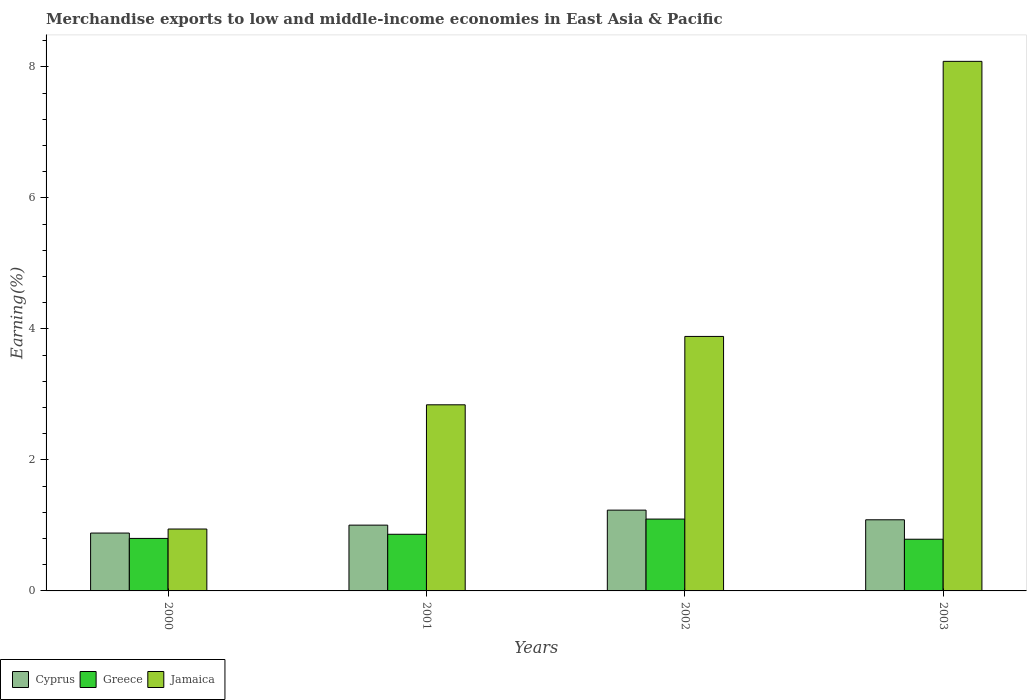How many groups of bars are there?
Provide a succinct answer. 4. Are the number of bars per tick equal to the number of legend labels?
Give a very brief answer. Yes. What is the label of the 1st group of bars from the left?
Your answer should be very brief. 2000. What is the percentage of amount earned from merchandise exports in Cyprus in 2003?
Ensure brevity in your answer.  1.09. Across all years, what is the maximum percentage of amount earned from merchandise exports in Greece?
Give a very brief answer. 1.1. Across all years, what is the minimum percentage of amount earned from merchandise exports in Greece?
Keep it short and to the point. 0.79. In which year was the percentage of amount earned from merchandise exports in Cyprus maximum?
Offer a very short reply. 2002. In which year was the percentage of amount earned from merchandise exports in Jamaica minimum?
Provide a succinct answer. 2000. What is the total percentage of amount earned from merchandise exports in Jamaica in the graph?
Make the answer very short. 15.76. What is the difference between the percentage of amount earned from merchandise exports in Cyprus in 2000 and that in 2001?
Provide a short and direct response. -0.12. What is the difference between the percentage of amount earned from merchandise exports in Greece in 2001 and the percentage of amount earned from merchandise exports in Cyprus in 2002?
Give a very brief answer. -0.37. What is the average percentage of amount earned from merchandise exports in Greece per year?
Make the answer very short. 0.89. In the year 2000, what is the difference between the percentage of amount earned from merchandise exports in Cyprus and percentage of amount earned from merchandise exports in Jamaica?
Ensure brevity in your answer.  -0.06. What is the ratio of the percentage of amount earned from merchandise exports in Cyprus in 2001 to that in 2002?
Provide a succinct answer. 0.81. Is the percentage of amount earned from merchandise exports in Greece in 2001 less than that in 2002?
Provide a succinct answer. Yes. Is the difference between the percentage of amount earned from merchandise exports in Cyprus in 2002 and 2003 greater than the difference between the percentage of amount earned from merchandise exports in Jamaica in 2002 and 2003?
Give a very brief answer. Yes. What is the difference between the highest and the second highest percentage of amount earned from merchandise exports in Jamaica?
Offer a very short reply. 4.2. What is the difference between the highest and the lowest percentage of amount earned from merchandise exports in Greece?
Make the answer very short. 0.31. In how many years, is the percentage of amount earned from merchandise exports in Cyprus greater than the average percentage of amount earned from merchandise exports in Cyprus taken over all years?
Ensure brevity in your answer.  2. Is the sum of the percentage of amount earned from merchandise exports in Cyprus in 2000 and 2003 greater than the maximum percentage of amount earned from merchandise exports in Jamaica across all years?
Provide a short and direct response. No. What does the 3rd bar from the left in 2000 represents?
Your answer should be very brief. Jamaica. What does the 3rd bar from the right in 2001 represents?
Your response must be concise. Cyprus. How many years are there in the graph?
Your answer should be very brief. 4. Are the values on the major ticks of Y-axis written in scientific E-notation?
Provide a succinct answer. No. Where does the legend appear in the graph?
Keep it short and to the point. Bottom left. What is the title of the graph?
Provide a succinct answer. Merchandise exports to low and middle-income economies in East Asia & Pacific. Does "Zimbabwe" appear as one of the legend labels in the graph?
Keep it short and to the point. No. What is the label or title of the X-axis?
Keep it short and to the point. Years. What is the label or title of the Y-axis?
Make the answer very short. Earning(%). What is the Earning(%) in Cyprus in 2000?
Provide a short and direct response. 0.88. What is the Earning(%) of Greece in 2000?
Ensure brevity in your answer.  0.8. What is the Earning(%) in Jamaica in 2000?
Offer a very short reply. 0.94. What is the Earning(%) of Cyprus in 2001?
Offer a terse response. 1. What is the Earning(%) in Greece in 2001?
Offer a very short reply. 0.86. What is the Earning(%) of Jamaica in 2001?
Your answer should be compact. 2.84. What is the Earning(%) of Cyprus in 2002?
Offer a terse response. 1.23. What is the Earning(%) of Greece in 2002?
Give a very brief answer. 1.1. What is the Earning(%) in Jamaica in 2002?
Provide a short and direct response. 3.89. What is the Earning(%) of Cyprus in 2003?
Provide a short and direct response. 1.09. What is the Earning(%) in Greece in 2003?
Provide a succinct answer. 0.79. What is the Earning(%) in Jamaica in 2003?
Provide a succinct answer. 8.08. Across all years, what is the maximum Earning(%) of Cyprus?
Your response must be concise. 1.23. Across all years, what is the maximum Earning(%) in Greece?
Offer a terse response. 1.1. Across all years, what is the maximum Earning(%) in Jamaica?
Keep it short and to the point. 8.08. Across all years, what is the minimum Earning(%) in Cyprus?
Make the answer very short. 0.88. Across all years, what is the minimum Earning(%) in Greece?
Offer a terse response. 0.79. Across all years, what is the minimum Earning(%) in Jamaica?
Keep it short and to the point. 0.94. What is the total Earning(%) in Cyprus in the graph?
Offer a very short reply. 4.21. What is the total Earning(%) in Greece in the graph?
Offer a terse response. 3.55. What is the total Earning(%) in Jamaica in the graph?
Provide a succinct answer. 15.76. What is the difference between the Earning(%) in Cyprus in 2000 and that in 2001?
Your answer should be compact. -0.12. What is the difference between the Earning(%) of Greece in 2000 and that in 2001?
Offer a terse response. -0.06. What is the difference between the Earning(%) in Jamaica in 2000 and that in 2001?
Offer a terse response. -1.9. What is the difference between the Earning(%) of Cyprus in 2000 and that in 2002?
Your response must be concise. -0.35. What is the difference between the Earning(%) in Greece in 2000 and that in 2002?
Offer a very short reply. -0.3. What is the difference between the Earning(%) in Jamaica in 2000 and that in 2002?
Your answer should be very brief. -2.94. What is the difference between the Earning(%) in Cyprus in 2000 and that in 2003?
Your response must be concise. -0.2. What is the difference between the Earning(%) of Greece in 2000 and that in 2003?
Provide a succinct answer. 0.01. What is the difference between the Earning(%) of Jamaica in 2000 and that in 2003?
Provide a succinct answer. -7.14. What is the difference between the Earning(%) in Cyprus in 2001 and that in 2002?
Make the answer very short. -0.23. What is the difference between the Earning(%) in Greece in 2001 and that in 2002?
Your response must be concise. -0.23. What is the difference between the Earning(%) of Jamaica in 2001 and that in 2002?
Keep it short and to the point. -1.04. What is the difference between the Earning(%) of Cyprus in 2001 and that in 2003?
Your answer should be compact. -0.08. What is the difference between the Earning(%) of Greece in 2001 and that in 2003?
Provide a succinct answer. 0.08. What is the difference between the Earning(%) in Jamaica in 2001 and that in 2003?
Provide a succinct answer. -5.24. What is the difference between the Earning(%) of Cyprus in 2002 and that in 2003?
Make the answer very short. 0.15. What is the difference between the Earning(%) of Greece in 2002 and that in 2003?
Provide a short and direct response. 0.31. What is the difference between the Earning(%) in Jamaica in 2002 and that in 2003?
Offer a very short reply. -4.2. What is the difference between the Earning(%) in Cyprus in 2000 and the Earning(%) in Greece in 2001?
Your response must be concise. 0.02. What is the difference between the Earning(%) of Cyprus in 2000 and the Earning(%) of Jamaica in 2001?
Your answer should be very brief. -1.96. What is the difference between the Earning(%) of Greece in 2000 and the Earning(%) of Jamaica in 2001?
Your response must be concise. -2.04. What is the difference between the Earning(%) in Cyprus in 2000 and the Earning(%) in Greece in 2002?
Your answer should be very brief. -0.21. What is the difference between the Earning(%) of Cyprus in 2000 and the Earning(%) of Jamaica in 2002?
Make the answer very short. -3. What is the difference between the Earning(%) in Greece in 2000 and the Earning(%) in Jamaica in 2002?
Your answer should be very brief. -3.08. What is the difference between the Earning(%) in Cyprus in 2000 and the Earning(%) in Greece in 2003?
Make the answer very short. 0.09. What is the difference between the Earning(%) of Cyprus in 2000 and the Earning(%) of Jamaica in 2003?
Ensure brevity in your answer.  -7.2. What is the difference between the Earning(%) of Greece in 2000 and the Earning(%) of Jamaica in 2003?
Provide a succinct answer. -7.28. What is the difference between the Earning(%) in Cyprus in 2001 and the Earning(%) in Greece in 2002?
Your response must be concise. -0.09. What is the difference between the Earning(%) in Cyprus in 2001 and the Earning(%) in Jamaica in 2002?
Give a very brief answer. -2.88. What is the difference between the Earning(%) of Greece in 2001 and the Earning(%) of Jamaica in 2002?
Your answer should be very brief. -3.02. What is the difference between the Earning(%) in Cyprus in 2001 and the Earning(%) in Greece in 2003?
Your answer should be very brief. 0.22. What is the difference between the Earning(%) in Cyprus in 2001 and the Earning(%) in Jamaica in 2003?
Offer a very short reply. -7.08. What is the difference between the Earning(%) in Greece in 2001 and the Earning(%) in Jamaica in 2003?
Keep it short and to the point. -7.22. What is the difference between the Earning(%) in Cyprus in 2002 and the Earning(%) in Greece in 2003?
Provide a succinct answer. 0.44. What is the difference between the Earning(%) of Cyprus in 2002 and the Earning(%) of Jamaica in 2003?
Offer a terse response. -6.85. What is the difference between the Earning(%) of Greece in 2002 and the Earning(%) of Jamaica in 2003?
Give a very brief answer. -6.99. What is the average Earning(%) in Cyprus per year?
Provide a short and direct response. 1.05. What is the average Earning(%) of Greece per year?
Give a very brief answer. 0.89. What is the average Earning(%) of Jamaica per year?
Make the answer very short. 3.94. In the year 2000, what is the difference between the Earning(%) of Cyprus and Earning(%) of Greece?
Your answer should be compact. 0.08. In the year 2000, what is the difference between the Earning(%) in Cyprus and Earning(%) in Jamaica?
Make the answer very short. -0.06. In the year 2000, what is the difference between the Earning(%) of Greece and Earning(%) of Jamaica?
Your response must be concise. -0.14. In the year 2001, what is the difference between the Earning(%) of Cyprus and Earning(%) of Greece?
Offer a terse response. 0.14. In the year 2001, what is the difference between the Earning(%) in Cyprus and Earning(%) in Jamaica?
Offer a terse response. -1.84. In the year 2001, what is the difference between the Earning(%) in Greece and Earning(%) in Jamaica?
Provide a short and direct response. -1.98. In the year 2002, what is the difference between the Earning(%) in Cyprus and Earning(%) in Greece?
Offer a very short reply. 0.14. In the year 2002, what is the difference between the Earning(%) in Cyprus and Earning(%) in Jamaica?
Offer a terse response. -2.65. In the year 2002, what is the difference between the Earning(%) of Greece and Earning(%) of Jamaica?
Offer a terse response. -2.79. In the year 2003, what is the difference between the Earning(%) in Cyprus and Earning(%) in Greece?
Make the answer very short. 0.3. In the year 2003, what is the difference between the Earning(%) in Cyprus and Earning(%) in Jamaica?
Offer a terse response. -7. In the year 2003, what is the difference between the Earning(%) in Greece and Earning(%) in Jamaica?
Offer a very short reply. -7.3. What is the ratio of the Earning(%) of Cyprus in 2000 to that in 2001?
Offer a terse response. 0.88. What is the ratio of the Earning(%) of Greece in 2000 to that in 2001?
Give a very brief answer. 0.93. What is the ratio of the Earning(%) in Jamaica in 2000 to that in 2001?
Provide a short and direct response. 0.33. What is the ratio of the Earning(%) in Cyprus in 2000 to that in 2002?
Provide a succinct answer. 0.72. What is the ratio of the Earning(%) in Greece in 2000 to that in 2002?
Give a very brief answer. 0.73. What is the ratio of the Earning(%) of Jamaica in 2000 to that in 2002?
Offer a very short reply. 0.24. What is the ratio of the Earning(%) of Cyprus in 2000 to that in 2003?
Keep it short and to the point. 0.81. What is the ratio of the Earning(%) in Greece in 2000 to that in 2003?
Your response must be concise. 1.02. What is the ratio of the Earning(%) in Jamaica in 2000 to that in 2003?
Give a very brief answer. 0.12. What is the ratio of the Earning(%) in Cyprus in 2001 to that in 2002?
Your response must be concise. 0.81. What is the ratio of the Earning(%) of Greece in 2001 to that in 2002?
Offer a terse response. 0.79. What is the ratio of the Earning(%) of Jamaica in 2001 to that in 2002?
Your response must be concise. 0.73. What is the ratio of the Earning(%) of Cyprus in 2001 to that in 2003?
Offer a terse response. 0.92. What is the ratio of the Earning(%) of Greece in 2001 to that in 2003?
Give a very brief answer. 1.1. What is the ratio of the Earning(%) of Jamaica in 2001 to that in 2003?
Your answer should be compact. 0.35. What is the ratio of the Earning(%) in Cyprus in 2002 to that in 2003?
Ensure brevity in your answer.  1.14. What is the ratio of the Earning(%) in Greece in 2002 to that in 2003?
Ensure brevity in your answer.  1.39. What is the ratio of the Earning(%) of Jamaica in 2002 to that in 2003?
Your answer should be very brief. 0.48. What is the difference between the highest and the second highest Earning(%) in Cyprus?
Provide a short and direct response. 0.15. What is the difference between the highest and the second highest Earning(%) of Greece?
Provide a short and direct response. 0.23. What is the difference between the highest and the second highest Earning(%) of Jamaica?
Your response must be concise. 4.2. What is the difference between the highest and the lowest Earning(%) in Greece?
Your answer should be very brief. 0.31. What is the difference between the highest and the lowest Earning(%) in Jamaica?
Make the answer very short. 7.14. 